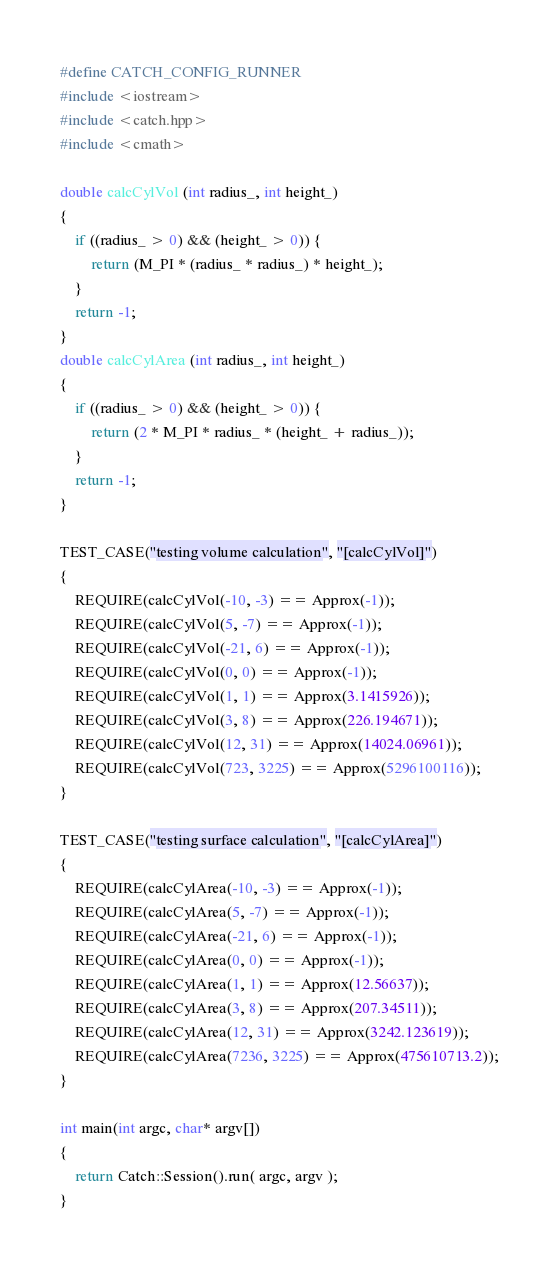<code> <loc_0><loc_0><loc_500><loc_500><_C++_>#define CATCH_CONFIG_RUNNER
#include <iostream>
#include <catch.hpp>
#include <cmath>

double calcCylVol (int radius_, int height_)
{
	if ((radius_ > 0) && (height_ > 0)) {
		return (M_PI * (radius_ * radius_) * height_); 
	}
	return -1;
}
double calcCylArea (int radius_, int height_)
{
	if ((radius_ > 0) && (height_ > 0)) {
		return (2 * M_PI * radius_ * (height_ + radius_));
	}
	return -1;
}

TEST_CASE("testing volume calculation", "[calcCylVol]")
{
	REQUIRE(calcCylVol(-10, -3) == Approx(-1));
	REQUIRE(calcCylVol(5, -7) == Approx(-1));
	REQUIRE(calcCylVol(-21, 6) == Approx(-1));
	REQUIRE(calcCylVol(0, 0) == Approx(-1));
	REQUIRE(calcCylVol(1, 1) == Approx(3.1415926));
	REQUIRE(calcCylVol(3, 8) == Approx(226.194671));
	REQUIRE(calcCylVol(12, 31) == Approx(14024.06961));
	REQUIRE(calcCylVol(723, 3225) == Approx(5296100116));
}

TEST_CASE("testing surface calculation", "[calcCylArea]")
{
	REQUIRE(calcCylArea(-10, -3) == Approx(-1));
	REQUIRE(calcCylArea(5, -7) == Approx(-1));
	REQUIRE(calcCylArea(-21, 6) == Approx(-1));
	REQUIRE(calcCylArea(0, 0) == Approx(-1));
	REQUIRE(calcCylArea(1, 1) == Approx(12.56637));
	REQUIRE(calcCylArea(3, 8) == Approx(207.34511));
	REQUIRE(calcCylArea(12, 31) == Approx(3242.123619));
	REQUIRE(calcCylArea(7236, 3225) == Approx(475610713.2));
}

int main(int argc, char* argv[])
{
	return Catch::Session().run( argc, argv );
}
</code> 